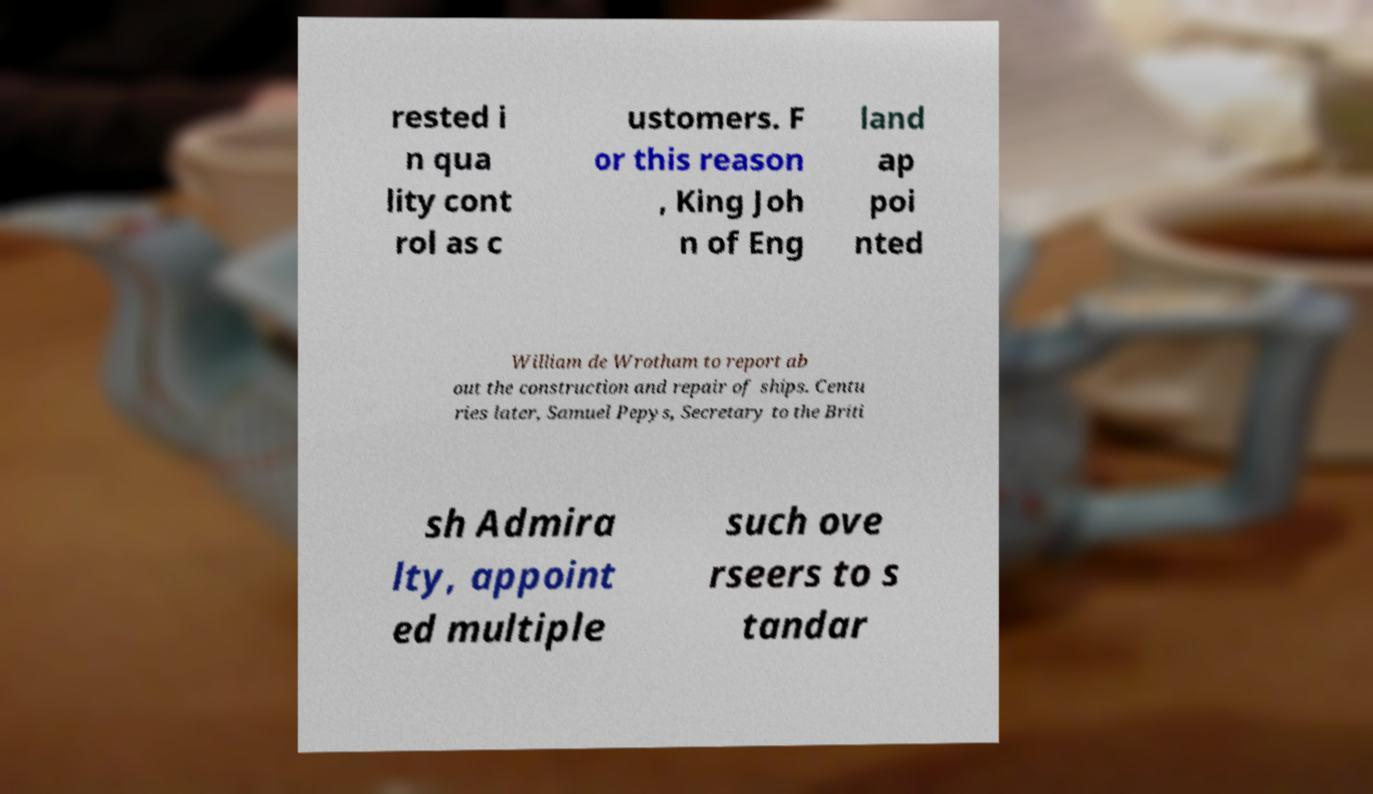I need the written content from this picture converted into text. Can you do that? rested i n qua lity cont rol as c ustomers. F or this reason , King Joh n of Eng land ap poi nted William de Wrotham to report ab out the construction and repair of ships. Centu ries later, Samuel Pepys, Secretary to the Briti sh Admira lty, appoint ed multiple such ove rseers to s tandar 